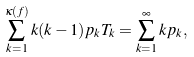<formula> <loc_0><loc_0><loc_500><loc_500>\sum _ { k = 1 } ^ { \kappa ( f ) } k ( k - 1 ) p _ { k } T _ { k } = \sum _ { k = 1 } ^ { \infty } k p _ { k } ,</formula> 